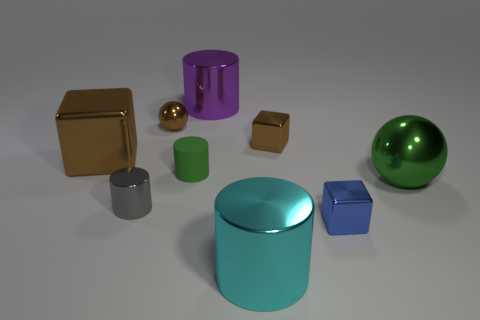Subtract all brown metallic blocks. How many blocks are left? 1 Subtract all blue cylinders. Subtract all blue spheres. How many cylinders are left? 4 Subtract all blocks. How many objects are left? 6 Subtract 1 green cylinders. How many objects are left? 8 Subtract all cyan shiny objects. Subtract all tiny gray things. How many objects are left? 7 Add 4 blue shiny blocks. How many blue shiny blocks are left? 5 Add 4 tiny objects. How many tiny objects exist? 9 